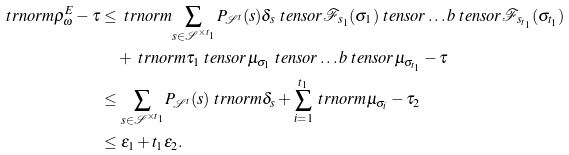Convert formula to latex. <formula><loc_0><loc_0><loc_500><loc_500>\ t r n o r m { \rho ^ { E } _ { \omega } - \tau } & \leq \ t r n o r m { \sum _ { s \in \mathcal { S } ^ { \times t _ { 1 } } } P _ { \mathcal { S } ^ { t } } ( s ) \delta _ { s } \ t e n s o r \mathcal { F } _ { s _ { 1 } } ( \sigma _ { 1 } ) \ t e n s o r \dots b \ t e n s o r \mathcal { F } _ { s _ { t _ { 1 } } } ( \sigma _ { t _ { 1 } } ) } \\ & \quad + \ t r n o r m { \tau _ { 1 } \ t e n s o r \mu _ { \sigma _ { 1 } } \ t e n s o r \dots b \ t e n s o r \mu _ { \sigma _ { t _ { 1 } } } - \tau } \\ & \leq \sum _ { s \in \mathcal { S } ^ { \times t _ { 1 } } } P _ { \mathcal { S } ^ { t } } ( s ) \ t r n o r m { \delta _ { s } } + \sum _ { i = 1 } ^ { t _ { 1 } } \ t r n o r m { \mu _ { \sigma _ { i } } - \tau _ { 2 } } \\ & \leq \epsilon _ { 1 } + t _ { 1 } \epsilon _ { 2 } .</formula> 